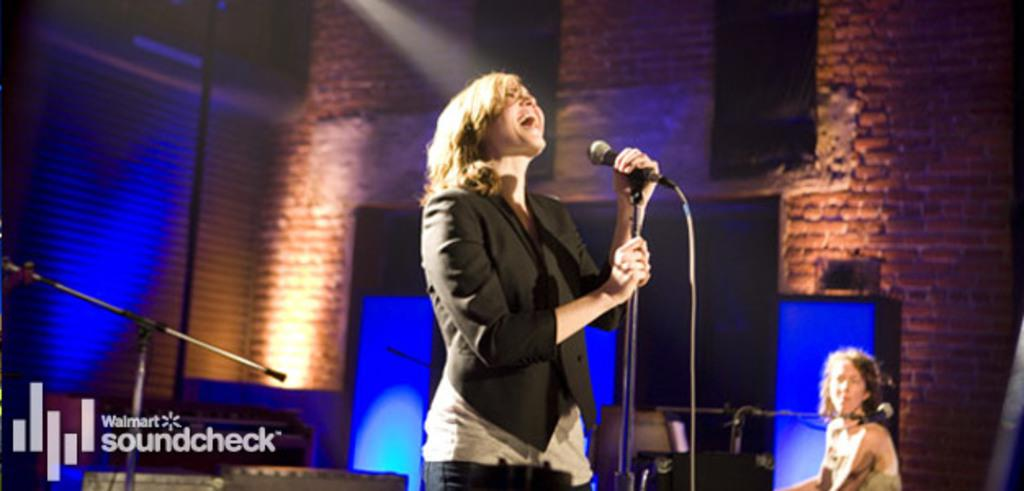What is the person in the image doing? The person is singing in the image. What is the person holding while singing? The person is holding a microphone. Can you describe the person next to the singer? There is another person at the right side of the image. What is the material and color of the walls in the background? The walls in the background are made of red bricks. What color are the eyes of the vest in the image? There is no vest present in the image, and therefore no eyes to describe. 